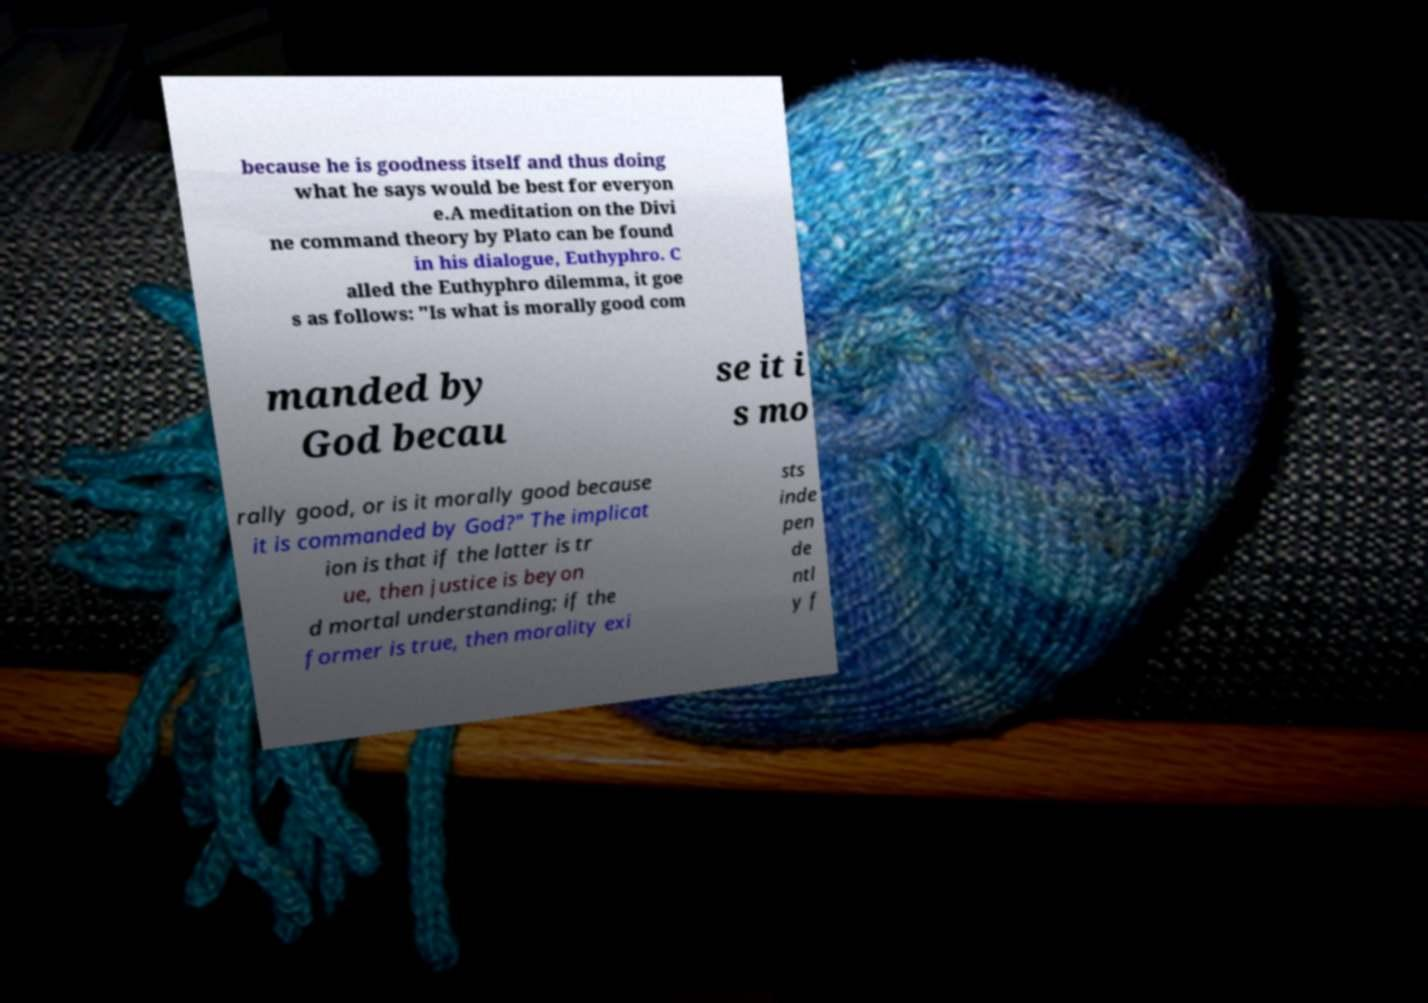Can you read and provide the text displayed in the image?This photo seems to have some interesting text. Can you extract and type it out for me? because he is goodness itself and thus doing what he says would be best for everyon e.A meditation on the Divi ne command theory by Plato can be found in his dialogue, Euthyphro. C alled the Euthyphro dilemma, it goe s as follows: "Is what is morally good com manded by God becau se it i s mo rally good, or is it morally good because it is commanded by God?" The implicat ion is that if the latter is tr ue, then justice is beyon d mortal understanding; if the former is true, then morality exi sts inde pen de ntl y f 